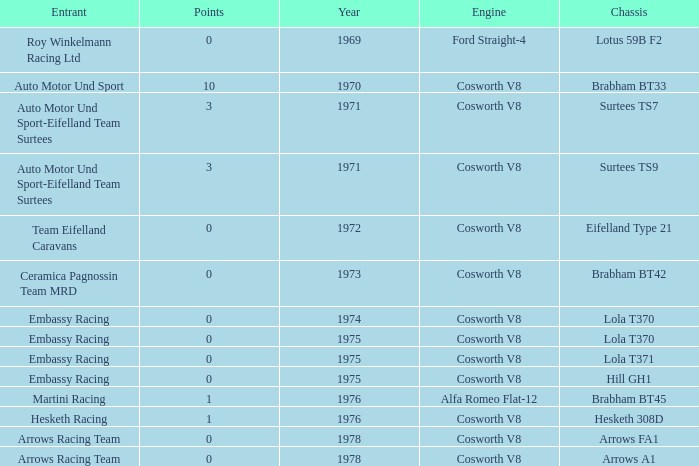In 1970, what entrant had a cosworth v8 engine? Auto Motor Und Sport. 